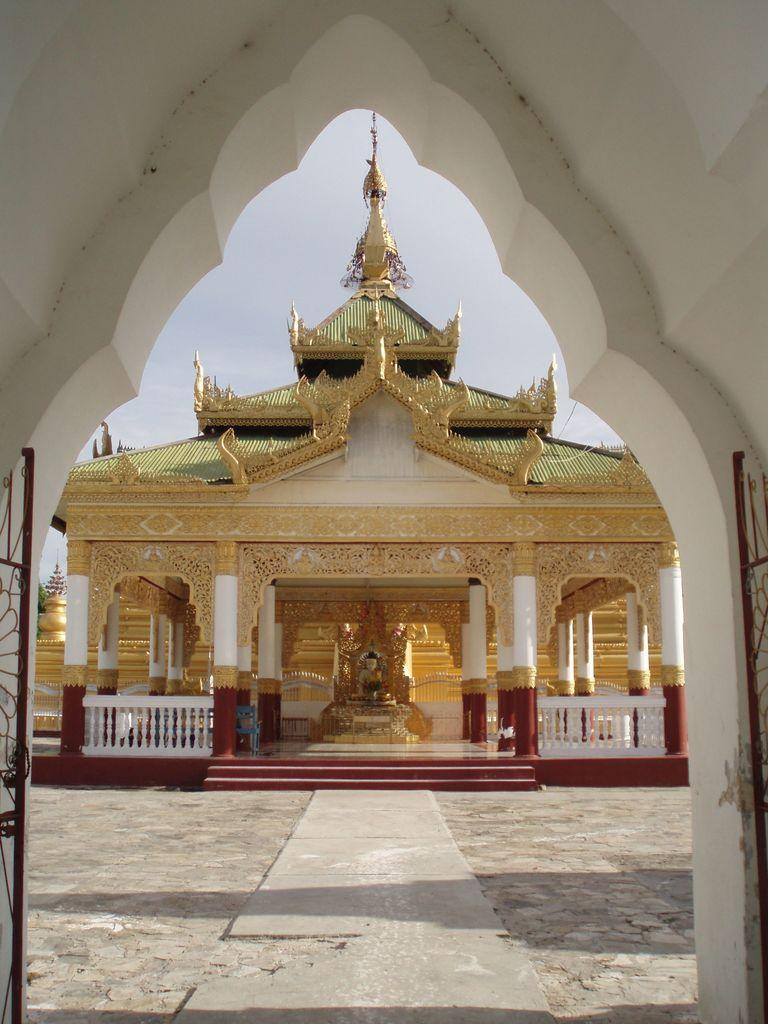What structure can be seen in the image? There is a gate in the image. What type of building is located in the middle of the image? There is a Buddhist temple in the middle of the image. What type of butter is used to decorate the gate in the image? There is no butter present in the image; it features a gate and a Buddhist temple. What color of marble can be seen in the Buddhist temple in the image? The image does not provide information about the color of marble in the Buddhist temple, if any. 